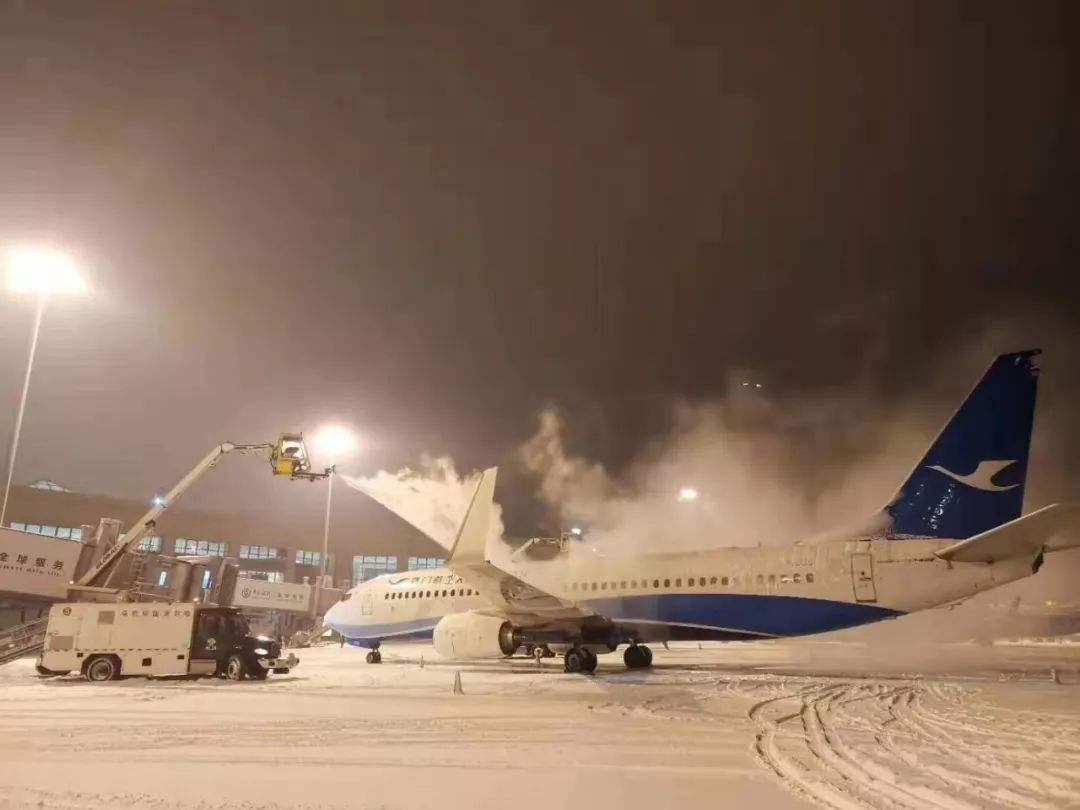What can you tell me about the airplane's design and possible model based on the image? Based on the image, the airplane has a narrow-body design, with the wings positioned at the lower part of the fuselage, typical of commercial jets. It appears to be a Boeing 737, known for its distinctive pointed nose and placement of the engines under the wings, which is a widely used model for short to medium-haul flights. 